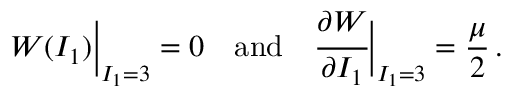Convert formula to latex. <formula><loc_0><loc_0><loc_500><loc_500>W ( I _ { 1 } ) { \left | } _ { I _ { 1 } = 3 } = 0 \quad a n d \quad \cfrac { \partial W } { \partial I _ { 1 } } { \right | } _ { I _ { 1 } = 3 } = { \frac { \mu } { 2 } } \, .</formula> 